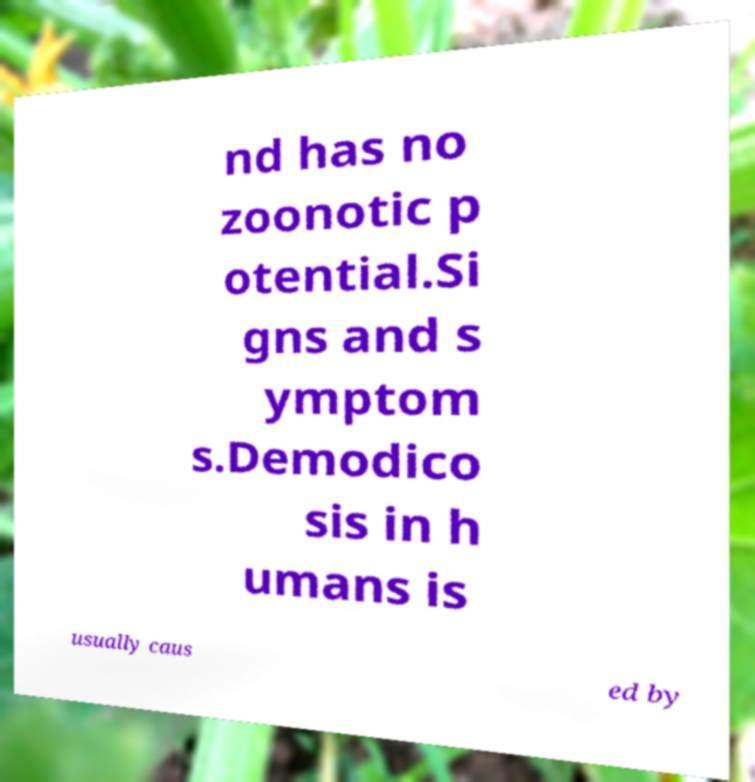There's text embedded in this image that I need extracted. Can you transcribe it verbatim? nd has no zoonotic p otential.Si gns and s ymptom s.Demodico sis in h umans is usually caus ed by 